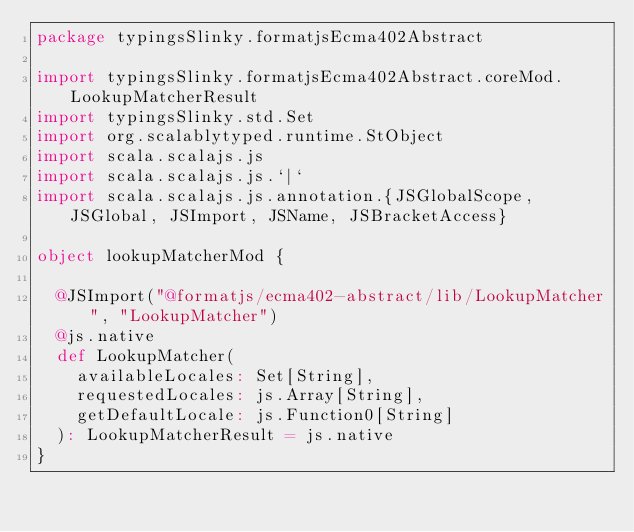<code> <loc_0><loc_0><loc_500><loc_500><_Scala_>package typingsSlinky.formatjsEcma402Abstract

import typingsSlinky.formatjsEcma402Abstract.coreMod.LookupMatcherResult
import typingsSlinky.std.Set
import org.scalablytyped.runtime.StObject
import scala.scalajs.js
import scala.scalajs.js.`|`
import scala.scalajs.js.annotation.{JSGlobalScope, JSGlobal, JSImport, JSName, JSBracketAccess}

object lookupMatcherMod {
  
  @JSImport("@formatjs/ecma402-abstract/lib/LookupMatcher", "LookupMatcher")
  @js.native
  def LookupMatcher(
    availableLocales: Set[String],
    requestedLocales: js.Array[String],
    getDefaultLocale: js.Function0[String]
  ): LookupMatcherResult = js.native
}
</code> 